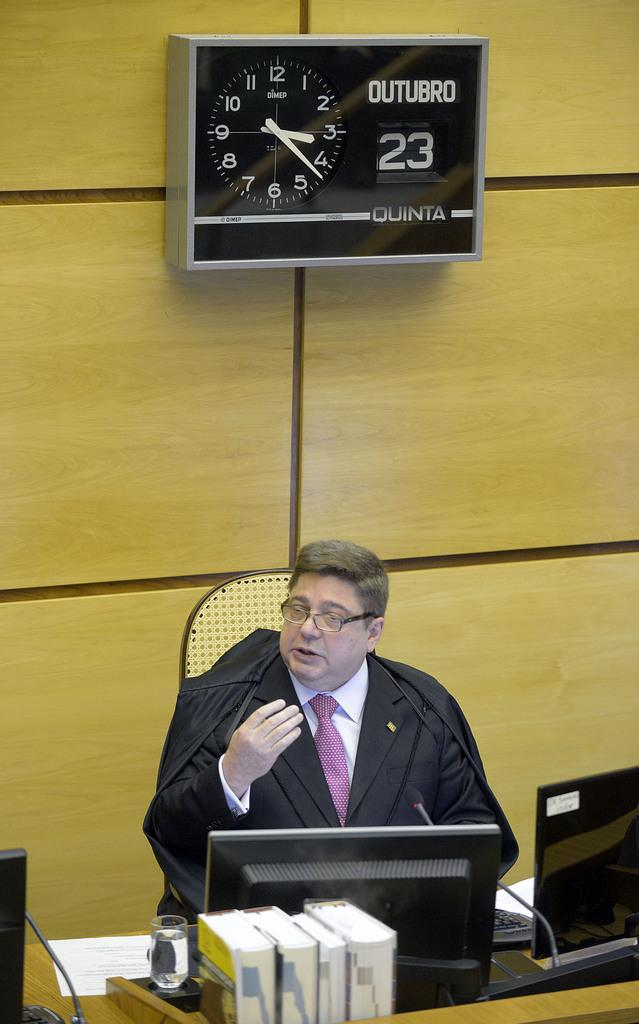<image>
Give a short and clear explanation of the subsequent image. a clock on the wall behind a judge that reads: Outubro 23 Quinta 